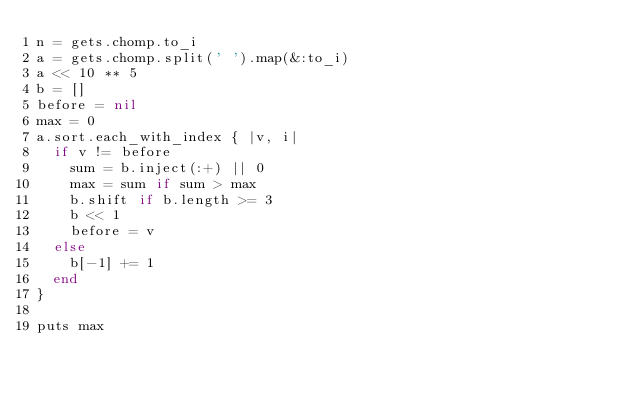<code> <loc_0><loc_0><loc_500><loc_500><_Ruby_>n = gets.chomp.to_i
a = gets.chomp.split(' ').map(&:to_i)
a << 10 ** 5
b = []
before = nil
max = 0
a.sort.each_with_index { |v, i|
  if v != before
    sum = b.inject(:+) || 0
    max = sum if sum > max
    b.shift if b.length >= 3
    b << 1
    before = v
  else
    b[-1] += 1
  end
}

puts max
</code> 